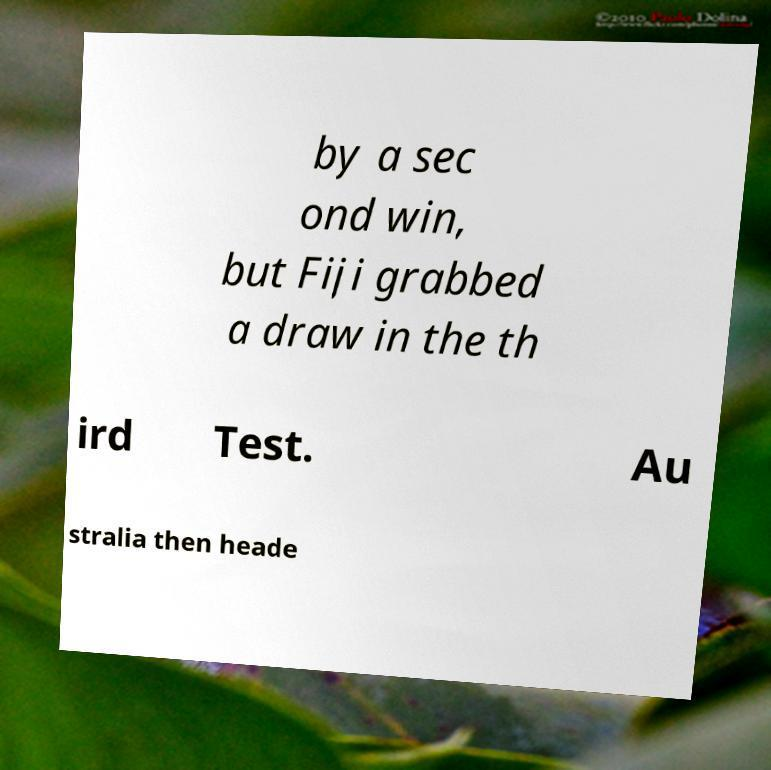Please read and relay the text visible in this image. What does it say? by a sec ond win, but Fiji grabbed a draw in the th ird Test. Au stralia then heade 